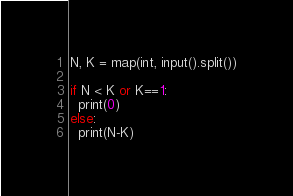<code> <loc_0><loc_0><loc_500><loc_500><_Python_>N, K = map(int, input().split())

if N < K or K==1:
  print(0)
else:
  print(N-K)</code> 